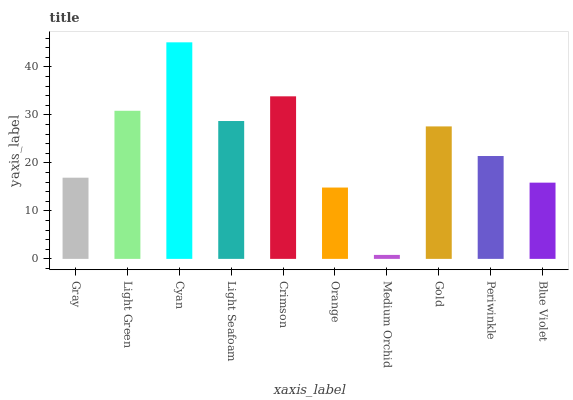Is Medium Orchid the minimum?
Answer yes or no. Yes. Is Cyan the maximum?
Answer yes or no. Yes. Is Light Green the minimum?
Answer yes or no. No. Is Light Green the maximum?
Answer yes or no. No. Is Light Green greater than Gray?
Answer yes or no. Yes. Is Gray less than Light Green?
Answer yes or no. Yes. Is Gray greater than Light Green?
Answer yes or no. No. Is Light Green less than Gray?
Answer yes or no. No. Is Gold the high median?
Answer yes or no. Yes. Is Periwinkle the low median?
Answer yes or no. Yes. Is Periwinkle the high median?
Answer yes or no. No. Is Cyan the low median?
Answer yes or no. No. 